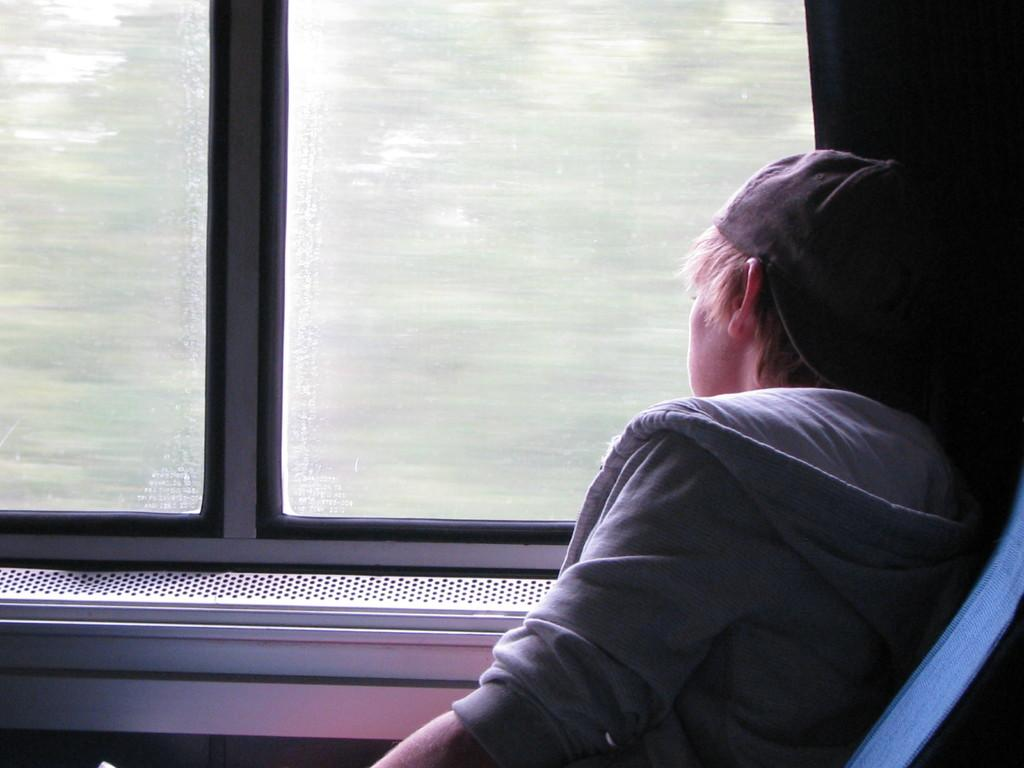What type of location is depicted in the image? The image is an inside view of a train. Can you describe the person in the image? There is a person sitting on the right side of the image. What can be seen in the background of the image? There is a window and cloth visible in the background of the image. What type of meal is being served to the expert in the image? There is no expert or meal present in the image; it is an inside view of a train with a person sitting on the right side. 